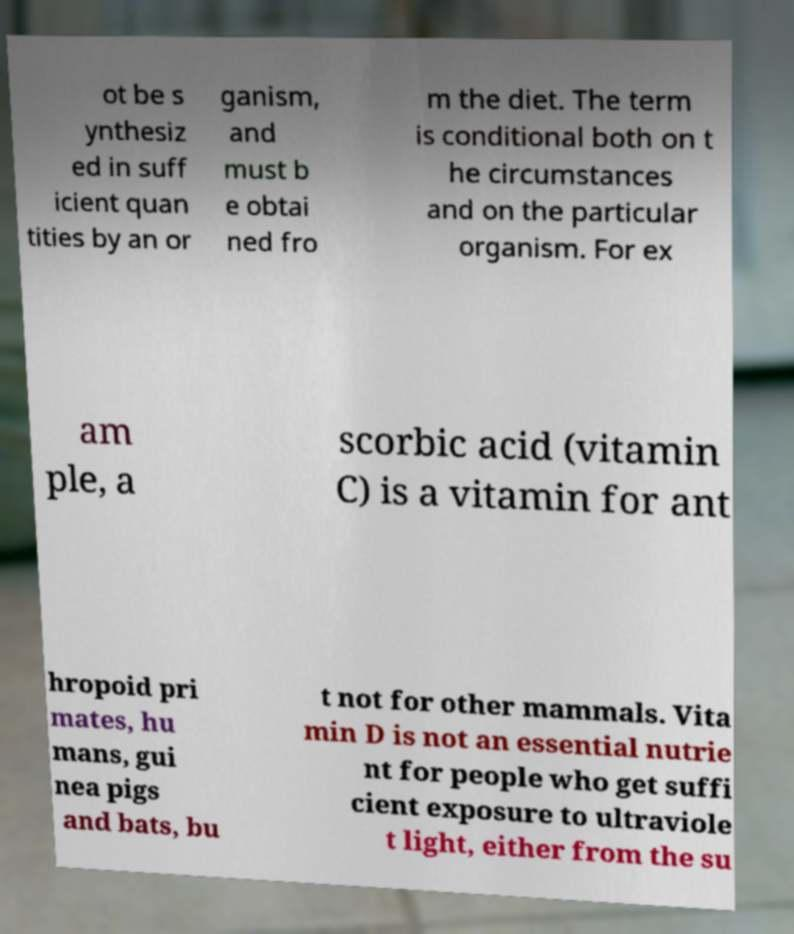There's text embedded in this image that I need extracted. Can you transcribe it verbatim? ot be s ynthesiz ed in suff icient quan tities by an or ganism, and must b e obtai ned fro m the diet. The term is conditional both on t he circumstances and on the particular organism. For ex am ple, a scorbic acid (vitamin C) is a vitamin for ant hropoid pri mates, hu mans, gui nea pigs and bats, bu t not for other mammals. Vita min D is not an essential nutrie nt for people who get suffi cient exposure to ultraviole t light, either from the su 